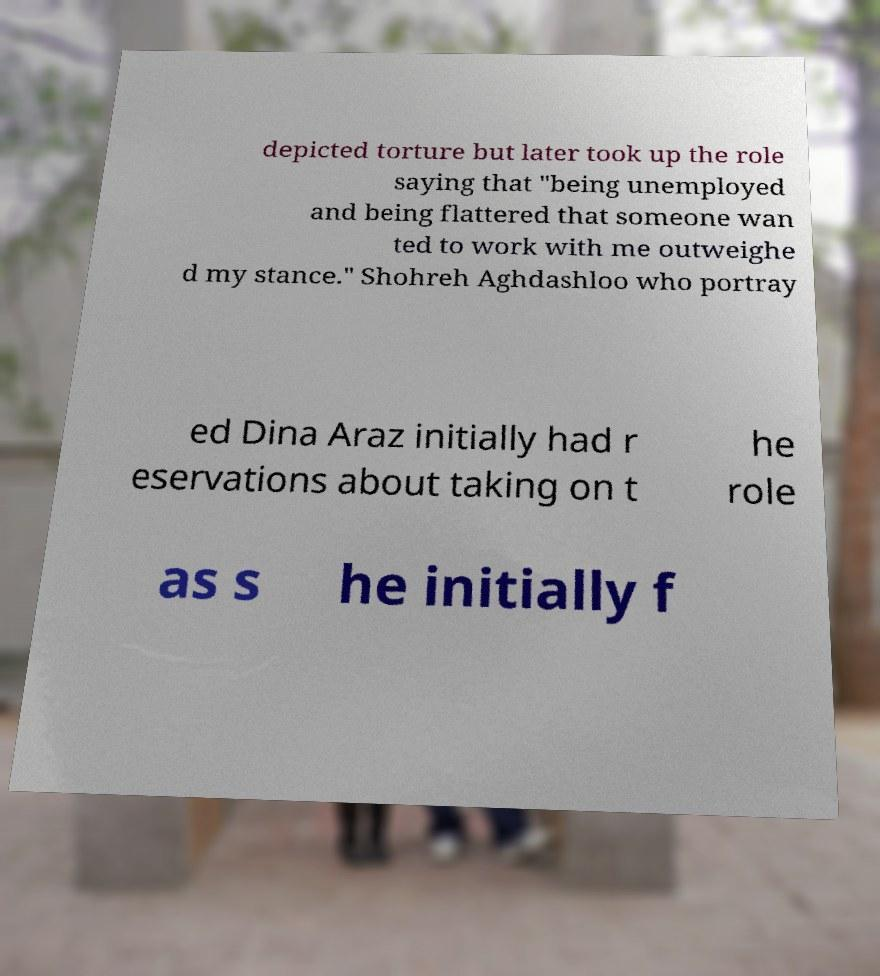Could you assist in decoding the text presented in this image and type it out clearly? depicted torture but later took up the role saying that "being unemployed and being flattered that someone wan ted to work with me outweighe d my stance." Shohreh Aghdashloo who portray ed Dina Araz initially had r eservations about taking on t he role as s he initially f 